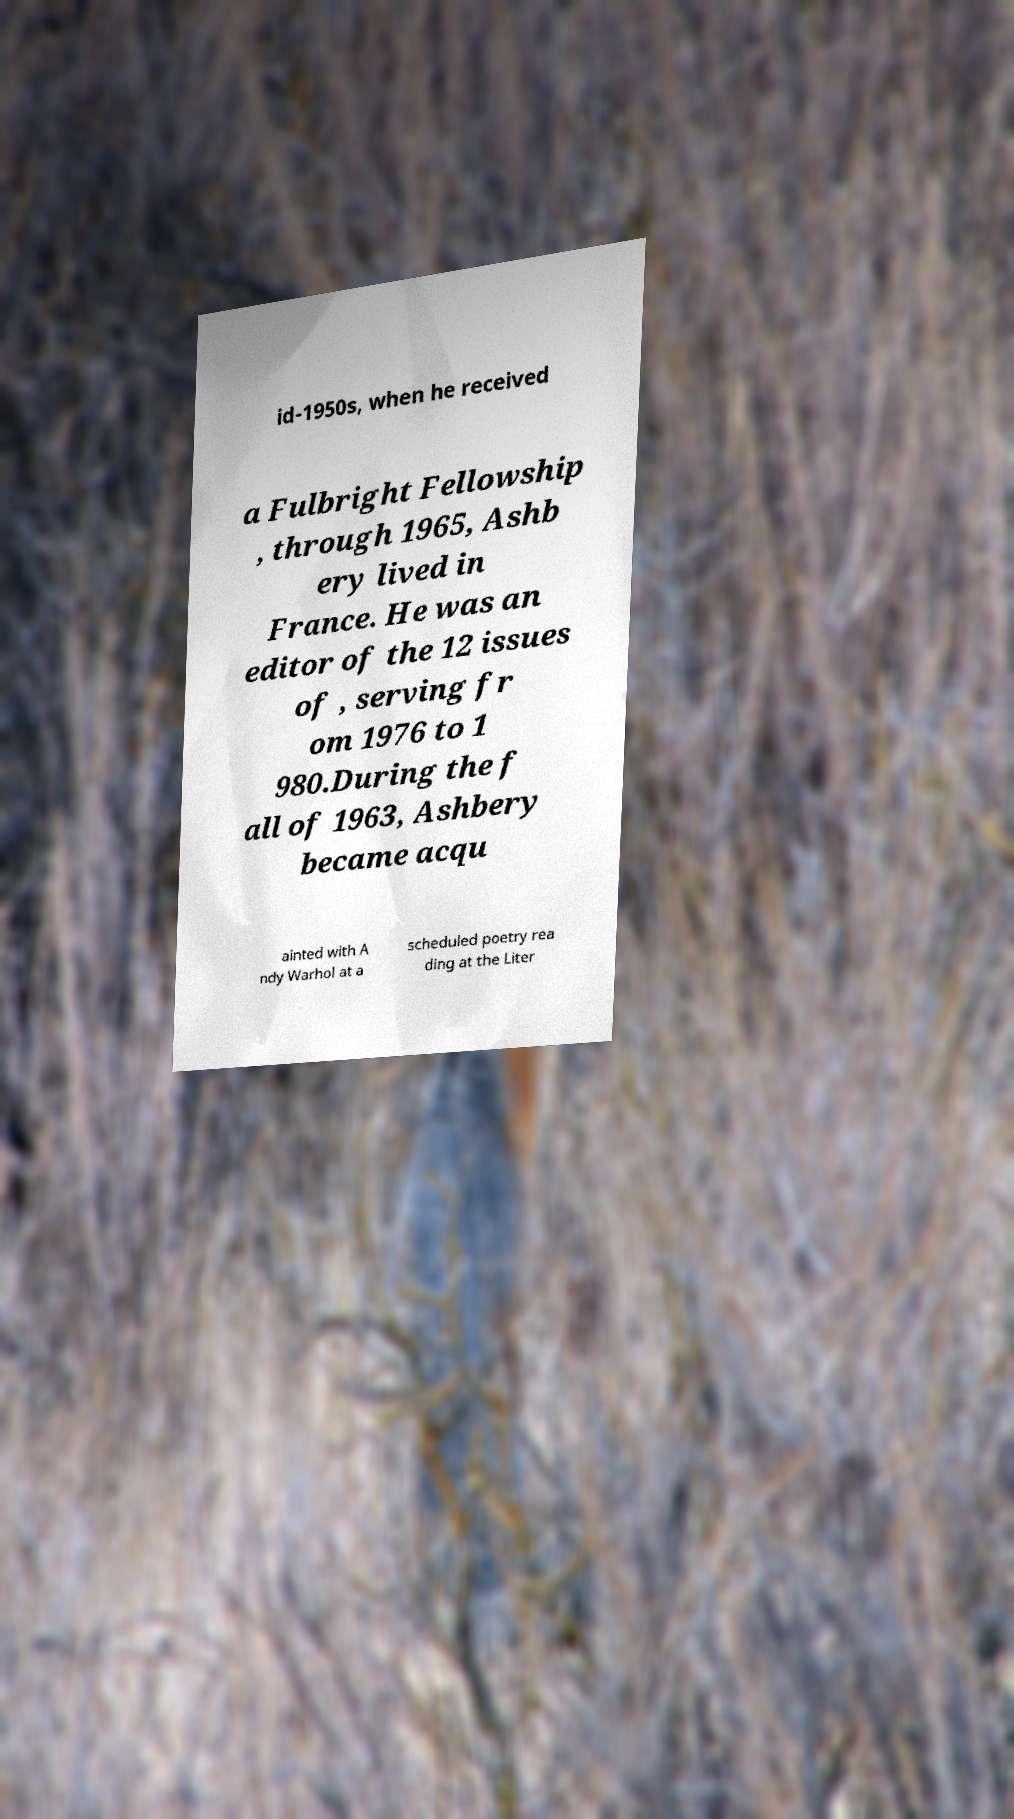There's text embedded in this image that I need extracted. Can you transcribe it verbatim? id-1950s, when he received a Fulbright Fellowship , through 1965, Ashb ery lived in France. He was an editor of the 12 issues of , serving fr om 1976 to 1 980.During the f all of 1963, Ashbery became acqu ainted with A ndy Warhol at a scheduled poetry rea ding at the Liter 